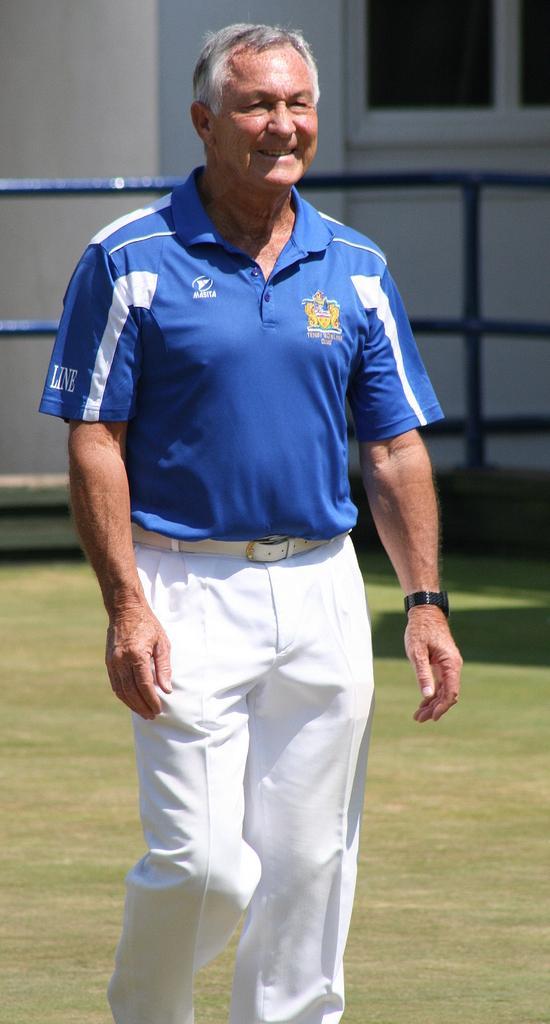In one or two sentences, can you explain what this image depicts? In the center of the image a man is standing. In the background of the image we can see a window, wall and rods are there. At the bottom of the image ground is there. 